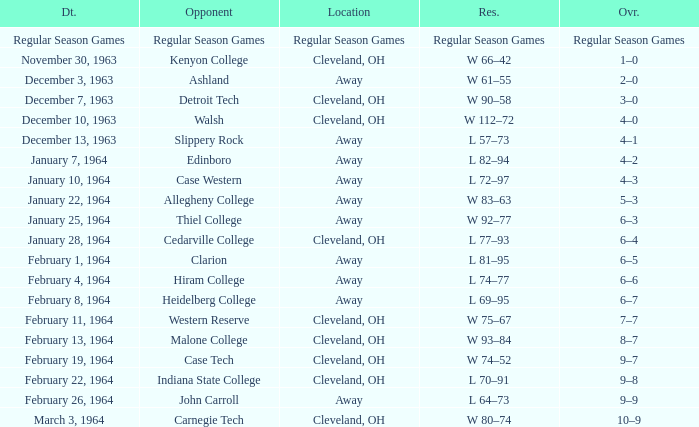What is the Location with a Date that is december 10, 1963? Cleveland, OH. 